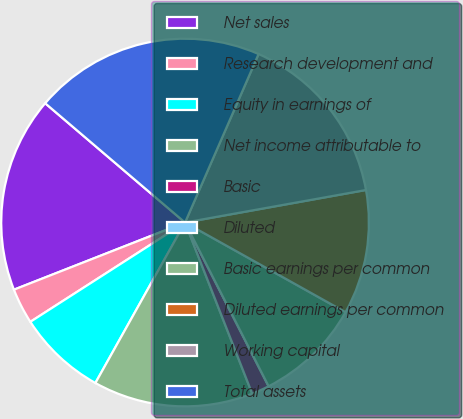<chart> <loc_0><loc_0><loc_500><loc_500><pie_chart><fcel>Net sales<fcel>Research development and<fcel>Equity in earnings of<fcel>Net income attributable to<fcel>Basic<fcel>Diluted<fcel>Basic earnings per common<fcel>Diluted earnings per common<fcel>Working capital<fcel>Total assets<nl><fcel>17.19%<fcel>3.13%<fcel>7.81%<fcel>14.06%<fcel>1.56%<fcel>0.0%<fcel>9.38%<fcel>10.94%<fcel>15.62%<fcel>20.31%<nl></chart> 